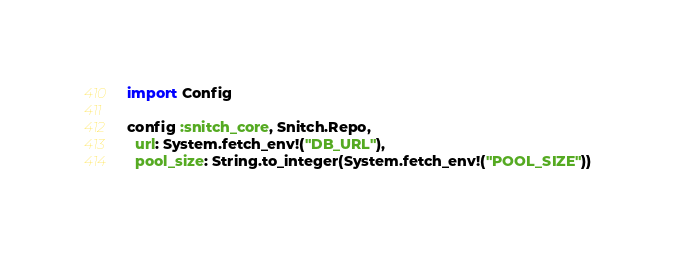Convert code to text. <code><loc_0><loc_0><loc_500><loc_500><_Elixir_>import Config

config :snitch_core, Snitch.Repo,
  url: System.fetch_env!("DB_URL"),
  pool_size: String.to_integer(System.fetch_env!("POOL_SIZE"))
</code> 